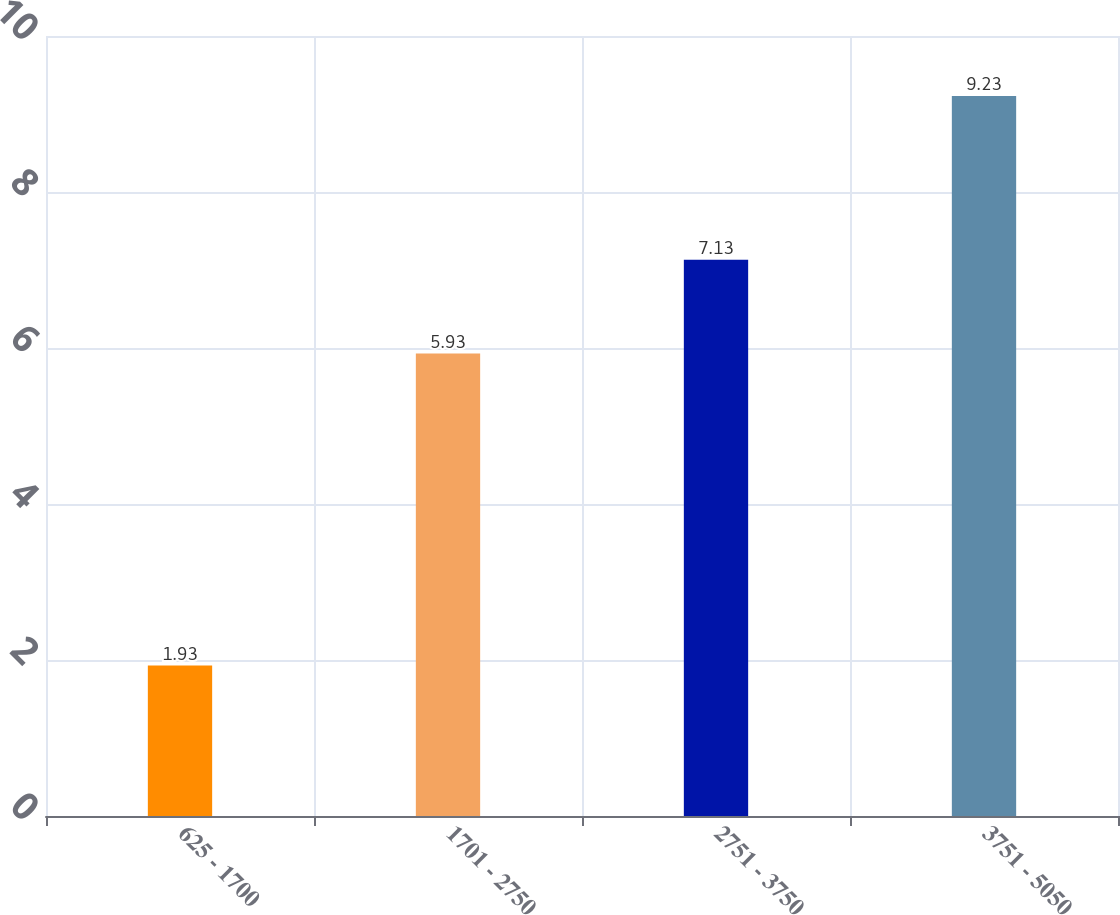Convert chart. <chart><loc_0><loc_0><loc_500><loc_500><bar_chart><fcel>625 - 1700<fcel>1701 - 2750<fcel>2751 - 3750<fcel>3751 - 5050<nl><fcel>1.93<fcel>5.93<fcel>7.13<fcel>9.23<nl></chart> 